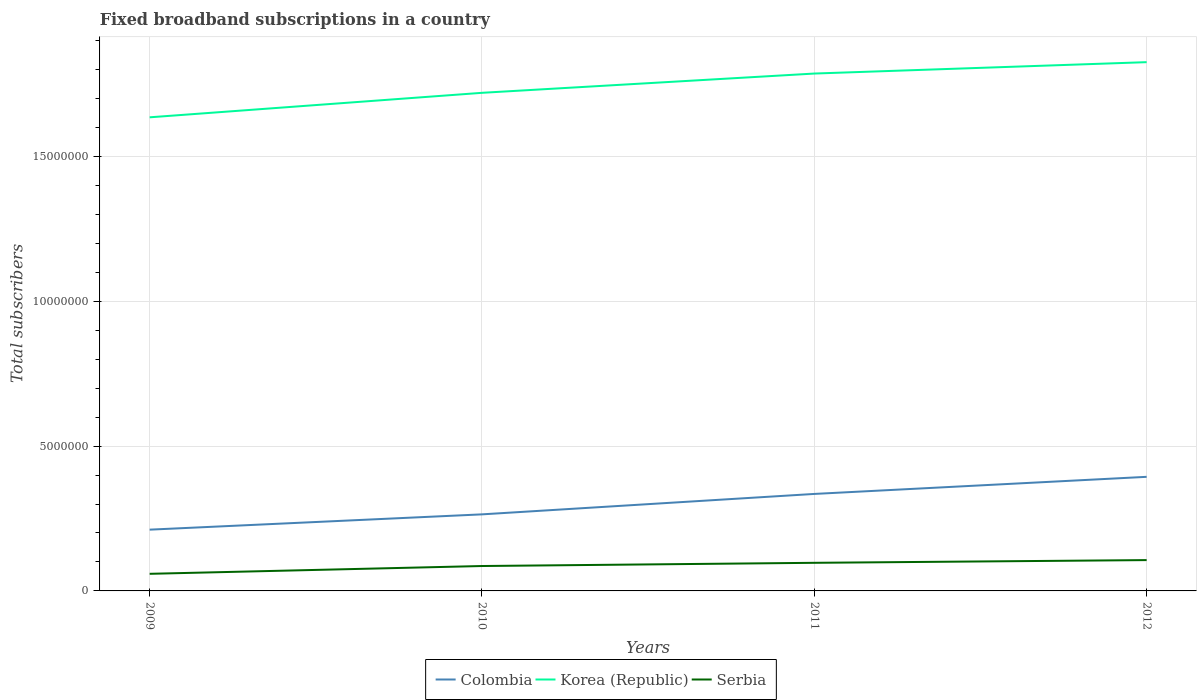How many different coloured lines are there?
Your answer should be compact. 3. Does the line corresponding to Colombia intersect with the line corresponding to Serbia?
Your answer should be compact. No. Across all years, what is the maximum number of broadband subscriptions in Serbia?
Make the answer very short. 5.91e+05. What is the total number of broadband subscriptions in Colombia in the graph?
Your answer should be compact. -1.82e+06. What is the difference between the highest and the second highest number of broadband subscriptions in Serbia?
Ensure brevity in your answer.  4.73e+05. How many years are there in the graph?
Provide a succinct answer. 4. What is the difference between two consecutive major ticks on the Y-axis?
Ensure brevity in your answer.  5.00e+06. Does the graph contain any zero values?
Ensure brevity in your answer.  No. Does the graph contain grids?
Your answer should be very brief. Yes. Where does the legend appear in the graph?
Ensure brevity in your answer.  Bottom center. How are the legend labels stacked?
Provide a succinct answer. Horizontal. What is the title of the graph?
Give a very brief answer. Fixed broadband subscriptions in a country. Does "Italy" appear as one of the legend labels in the graph?
Your response must be concise. No. What is the label or title of the Y-axis?
Your response must be concise. Total subscribers. What is the Total subscribers of Colombia in 2009?
Your answer should be very brief. 2.11e+06. What is the Total subscribers in Korea (Republic) in 2009?
Provide a succinct answer. 1.63e+07. What is the Total subscribers of Serbia in 2009?
Make the answer very short. 5.91e+05. What is the Total subscribers of Colombia in 2010?
Your answer should be very brief. 2.64e+06. What is the Total subscribers in Korea (Republic) in 2010?
Provide a short and direct response. 1.72e+07. What is the Total subscribers in Serbia in 2010?
Keep it short and to the point. 8.60e+05. What is the Total subscribers of Colombia in 2011?
Your answer should be compact. 3.35e+06. What is the Total subscribers of Korea (Republic) in 2011?
Give a very brief answer. 1.79e+07. What is the Total subscribers of Serbia in 2011?
Provide a succinct answer. 9.70e+05. What is the Total subscribers of Colombia in 2012?
Offer a terse response. 3.94e+06. What is the Total subscribers in Korea (Republic) in 2012?
Your answer should be compact. 1.83e+07. What is the Total subscribers in Serbia in 2012?
Provide a succinct answer. 1.06e+06. Across all years, what is the maximum Total subscribers in Colombia?
Provide a succinct answer. 3.94e+06. Across all years, what is the maximum Total subscribers of Korea (Republic)?
Keep it short and to the point. 1.83e+07. Across all years, what is the maximum Total subscribers in Serbia?
Offer a very short reply. 1.06e+06. Across all years, what is the minimum Total subscribers of Colombia?
Provide a succinct answer. 2.11e+06. Across all years, what is the minimum Total subscribers in Korea (Republic)?
Your answer should be very brief. 1.63e+07. Across all years, what is the minimum Total subscribers of Serbia?
Give a very brief answer. 5.91e+05. What is the total Total subscribers in Colombia in the graph?
Provide a short and direct response. 1.20e+07. What is the total Total subscribers of Korea (Republic) in the graph?
Your answer should be very brief. 6.97e+07. What is the total Total subscribers of Serbia in the graph?
Provide a succinct answer. 3.48e+06. What is the difference between the Total subscribers of Colombia in 2009 and that in 2010?
Offer a very short reply. -5.28e+05. What is the difference between the Total subscribers in Korea (Republic) in 2009 and that in 2010?
Your response must be concise. -8.46e+05. What is the difference between the Total subscribers of Serbia in 2009 and that in 2010?
Offer a very short reply. -2.69e+05. What is the difference between the Total subscribers in Colombia in 2009 and that in 2011?
Offer a terse response. -1.23e+06. What is the difference between the Total subscribers in Korea (Republic) in 2009 and that in 2011?
Offer a very short reply. -1.51e+06. What is the difference between the Total subscribers of Serbia in 2009 and that in 2011?
Your answer should be compact. -3.80e+05. What is the difference between the Total subscribers in Colombia in 2009 and that in 2012?
Ensure brevity in your answer.  -1.82e+06. What is the difference between the Total subscribers of Korea (Republic) in 2009 and that in 2012?
Give a very brief answer. -1.90e+06. What is the difference between the Total subscribers in Serbia in 2009 and that in 2012?
Offer a terse response. -4.73e+05. What is the difference between the Total subscribers in Colombia in 2010 and that in 2011?
Give a very brief answer. -7.05e+05. What is the difference between the Total subscribers of Korea (Republic) in 2010 and that in 2011?
Offer a terse response. -6.65e+05. What is the difference between the Total subscribers in Serbia in 2010 and that in 2011?
Your response must be concise. -1.11e+05. What is the difference between the Total subscribers of Colombia in 2010 and that in 2012?
Your response must be concise. -1.30e+06. What is the difference between the Total subscribers of Korea (Republic) in 2010 and that in 2012?
Keep it short and to the point. -1.06e+06. What is the difference between the Total subscribers of Serbia in 2010 and that in 2012?
Provide a short and direct response. -2.04e+05. What is the difference between the Total subscribers in Colombia in 2011 and that in 2012?
Make the answer very short. -5.91e+05. What is the difference between the Total subscribers of Korea (Republic) in 2011 and that in 2012?
Make the answer very short. -3.93e+05. What is the difference between the Total subscribers in Serbia in 2011 and that in 2012?
Give a very brief answer. -9.36e+04. What is the difference between the Total subscribers of Colombia in 2009 and the Total subscribers of Korea (Republic) in 2010?
Give a very brief answer. -1.51e+07. What is the difference between the Total subscribers of Colombia in 2009 and the Total subscribers of Serbia in 2010?
Your answer should be very brief. 1.25e+06. What is the difference between the Total subscribers in Korea (Republic) in 2009 and the Total subscribers in Serbia in 2010?
Offer a very short reply. 1.55e+07. What is the difference between the Total subscribers of Colombia in 2009 and the Total subscribers of Korea (Republic) in 2011?
Keep it short and to the point. -1.57e+07. What is the difference between the Total subscribers of Colombia in 2009 and the Total subscribers of Serbia in 2011?
Ensure brevity in your answer.  1.14e+06. What is the difference between the Total subscribers of Korea (Republic) in 2009 and the Total subscribers of Serbia in 2011?
Your response must be concise. 1.54e+07. What is the difference between the Total subscribers of Colombia in 2009 and the Total subscribers of Korea (Republic) in 2012?
Offer a very short reply. -1.61e+07. What is the difference between the Total subscribers in Colombia in 2009 and the Total subscribers in Serbia in 2012?
Make the answer very short. 1.05e+06. What is the difference between the Total subscribers in Korea (Republic) in 2009 and the Total subscribers in Serbia in 2012?
Provide a succinct answer. 1.53e+07. What is the difference between the Total subscribers of Colombia in 2010 and the Total subscribers of Korea (Republic) in 2011?
Provide a short and direct response. -1.52e+07. What is the difference between the Total subscribers of Colombia in 2010 and the Total subscribers of Serbia in 2011?
Your answer should be very brief. 1.67e+06. What is the difference between the Total subscribers of Korea (Republic) in 2010 and the Total subscribers of Serbia in 2011?
Make the answer very short. 1.62e+07. What is the difference between the Total subscribers of Colombia in 2010 and the Total subscribers of Korea (Republic) in 2012?
Keep it short and to the point. -1.56e+07. What is the difference between the Total subscribers in Colombia in 2010 and the Total subscribers in Serbia in 2012?
Offer a very short reply. 1.58e+06. What is the difference between the Total subscribers in Korea (Republic) in 2010 and the Total subscribers in Serbia in 2012?
Offer a terse response. 1.61e+07. What is the difference between the Total subscribers of Colombia in 2011 and the Total subscribers of Korea (Republic) in 2012?
Make the answer very short. -1.49e+07. What is the difference between the Total subscribers of Colombia in 2011 and the Total subscribers of Serbia in 2012?
Offer a terse response. 2.28e+06. What is the difference between the Total subscribers of Korea (Republic) in 2011 and the Total subscribers of Serbia in 2012?
Provide a short and direct response. 1.68e+07. What is the average Total subscribers in Colombia per year?
Your answer should be compact. 3.01e+06. What is the average Total subscribers of Korea (Republic) per year?
Provide a succinct answer. 1.74e+07. What is the average Total subscribers of Serbia per year?
Offer a terse response. 8.71e+05. In the year 2009, what is the difference between the Total subscribers in Colombia and Total subscribers in Korea (Republic)?
Offer a terse response. -1.42e+07. In the year 2009, what is the difference between the Total subscribers of Colombia and Total subscribers of Serbia?
Your answer should be very brief. 1.52e+06. In the year 2009, what is the difference between the Total subscribers of Korea (Republic) and Total subscribers of Serbia?
Provide a succinct answer. 1.58e+07. In the year 2010, what is the difference between the Total subscribers in Colombia and Total subscribers in Korea (Republic)?
Provide a succinct answer. -1.46e+07. In the year 2010, what is the difference between the Total subscribers of Colombia and Total subscribers of Serbia?
Provide a short and direct response. 1.78e+06. In the year 2010, what is the difference between the Total subscribers of Korea (Republic) and Total subscribers of Serbia?
Make the answer very short. 1.63e+07. In the year 2011, what is the difference between the Total subscribers of Colombia and Total subscribers of Korea (Republic)?
Provide a succinct answer. -1.45e+07. In the year 2011, what is the difference between the Total subscribers of Colombia and Total subscribers of Serbia?
Your answer should be very brief. 2.38e+06. In the year 2011, what is the difference between the Total subscribers of Korea (Republic) and Total subscribers of Serbia?
Provide a short and direct response. 1.69e+07. In the year 2012, what is the difference between the Total subscribers in Colombia and Total subscribers in Korea (Republic)?
Make the answer very short. -1.43e+07. In the year 2012, what is the difference between the Total subscribers of Colombia and Total subscribers of Serbia?
Offer a very short reply. 2.87e+06. In the year 2012, what is the difference between the Total subscribers of Korea (Republic) and Total subscribers of Serbia?
Your answer should be very brief. 1.72e+07. What is the ratio of the Total subscribers of Colombia in 2009 to that in 2010?
Your answer should be compact. 0.8. What is the ratio of the Total subscribers of Korea (Republic) in 2009 to that in 2010?
Your answer should be compact. 0.95. What is the ratio of the Total subscribers of Serbia in 2009 to that in 2010?
Provide a short and direct response. 0.69. What is the ratio of the Total subscribers of Colombia in 2009 to that in 2011?
Offer a very short reply. 0.63. What is the ratio of the Total subscribers of Korea (Republic) in 2009 to that in 2011?
Provide a short and direct response. 0.92. What is the ratio of the Total subscribers of Serbia in 2009 to that in 2011?
Your answer should be very brief. 0.61. What is the ratio of the Total subscribers in Colombia in 2009 to that in 2012?
Keep it short and to the point. 0.54. What is the ratio of the Total subscribers in Korea (Republic) in 2009 to that in 2012?
Your answer should be very brief. 0.9. What is the ratio of the Total subscribers in Serbia in 2009 to that in 2012?
Ensure brevity in your answer.  0.56. What is the ratio of the Total subscribers in Colombia in 2010 to that in 2011?
Keep it short and to the point. 0.79. What is the ratio of the Total subscribers of Korea (Republic) in 2010 to that in 2011?
Your answer should be very brief. 0.96. What is the ratio of the Total subscribers of Serbia in 2010 to that in 2011?
Your answer should be very brief. 0.89. What is the ratio of the Total subscribers in Colombia in 2010 to that in 2012?
Your response must be concise. 0.67. What is the ratio of the Total subscribers of Korea (Republic) in 2010 to that in 2012?
Offer a terse response. 0.94. What is the ratio of the Total subscribers of Serbia in 2010 to that in 2012?
Your answer should be compact. 0.81. What is the ratio of the Total subscribers of Colombia in 2011 to that in 2012?
Your answer should be compact. 0.85. What is the ratio of the Total subscribers in Korea (Republic) in 2011 to that in 2012?
Offer a very short reply. 0.98. What is the ratio of the Total subscribers of Serbia in 2011 to that in 2012?
Your answer should be compact. 0.91. What is the difference between the highest and the second highest Total subscribers of Colombia?
Provide a succinct answer. 5.91e+05. What is the difference between the highest and the second highest Total subscribers of Korea (Republic)?
Make the answer very short. 3.93e+05. What is the difference between the highest and the second highest Total subscribers in Serbia?
Your answer should be compact. 9.36e+04. What is the difference between the highest and the lowest Total subscribers of Colombia?
Offer a terse response. 1.82e+06. What is the difference between the highest and the lowest Total subscribers in Korea (Republic)?
Keep it short and to the point. 1.90e+06. What is the difference between the highest and the lowest Total subscribers in Serbia?
Offer a very short reply. 4.73e+05. 